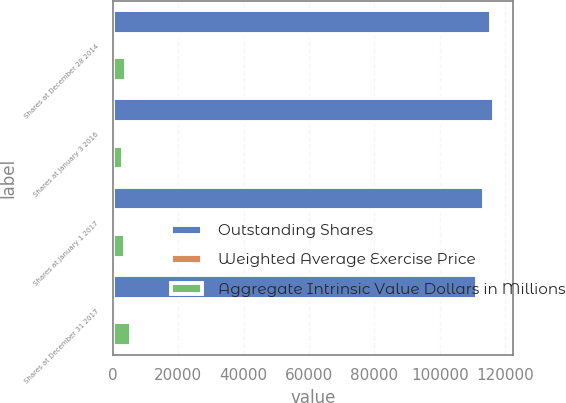Convert chart to OTSL. <chart><loc_0><loc_0><loc_500><loc_500><stacked_bar_chart><ecel><fcel>Shares at December 28 2014<fcel>Shares at January 3 2016<fcel>Shares at January 1 2017<fcel>Shares at December 31 2017<nl><fcel>Outstanding Shares<fcel>115712<fcel>116517<fcel>113455<fcel>111306<nl><fcel>Weighted Average Exercise Price<fcel>70.37<fcel>76.41<fcel>83.16<fcel>90.48<nl><fcel>Aggregate Intrinsic Value Dollars in Millions<fcel>4014<fcel>3065<fcel>3636<fcel>5480<nl></chart> 